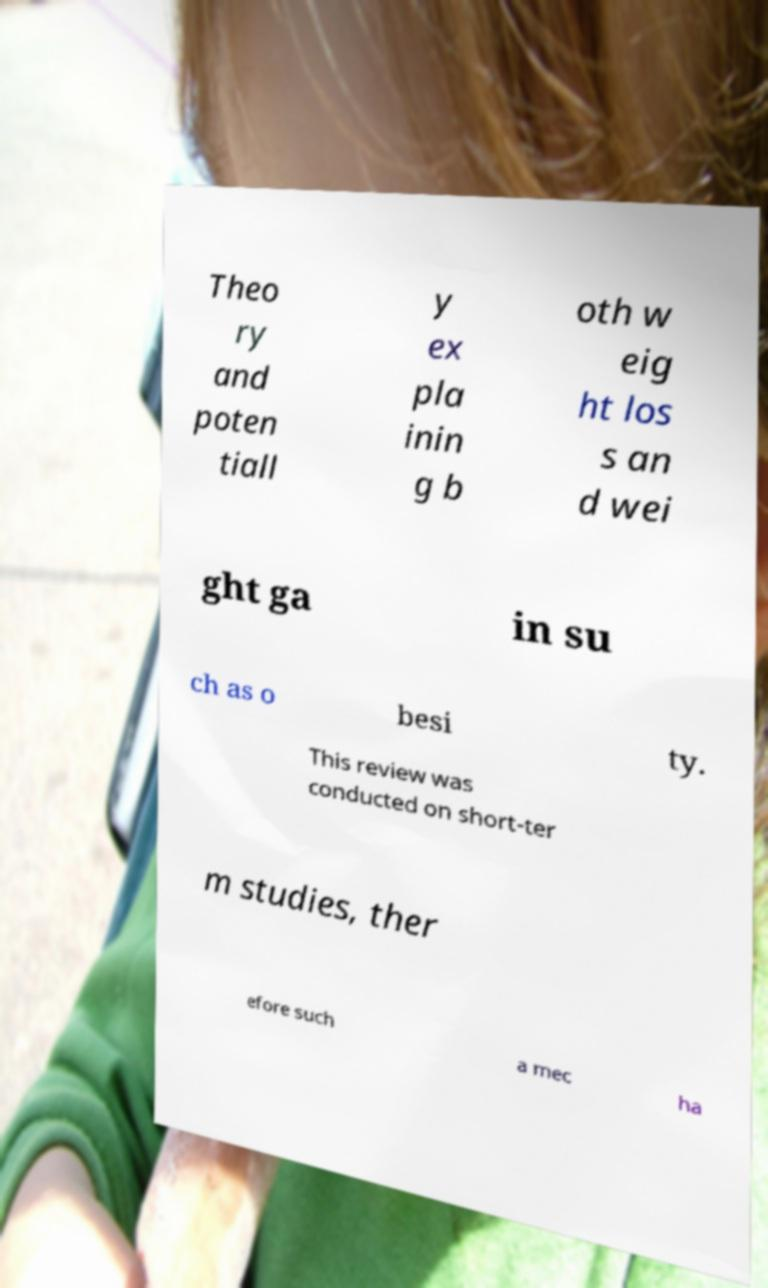What messages or text are displayed in this image? I need them in a readable, typed format. Theo ry and poten tiall y ex pla inin g b oth w eig ht los s an d wei ght ga in su ch as o besi ty. This review was conducted on short-ter m studies, ther efore such a mec ha 